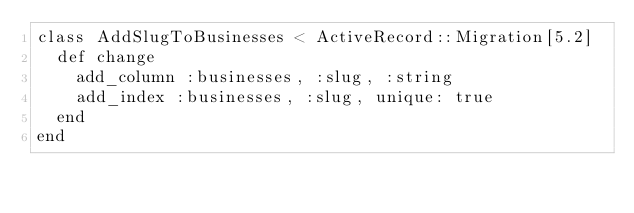Convert code to text. <code><loc_0><loc_0><loc_500><loc_500><_Ruby_>class AddSlugToBusinesses < ActiveRecord::Migration[5.2]
  def change
    add_column :businesses, :slug, :string
    add_index :businesses, :slug, unique: true
  end
end
</code> 